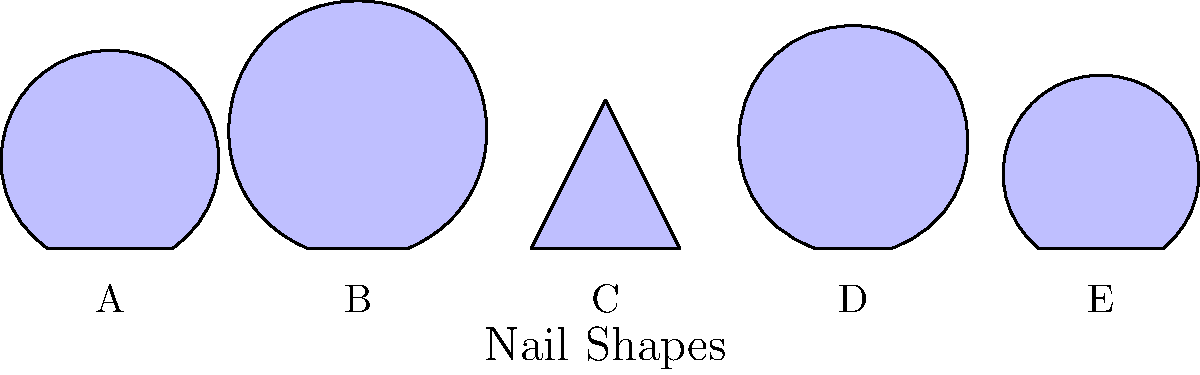Which nail shape shown in the diagram would be best suited for creating intricate, detailed nail art designs with multiple small elements? To determine the best nail shape for intricate, detailed nail art designs with multiple small elements, we need to consider the surface area and shape of each option:

1. Shape A: This shape has a moderate width and height, providing a good balance of space.
2. Shape B: This shape is tall and narrow, which might limit the space for intricate designs.
3. Shape C: This shape has a wide, flat top, offering the most surface area for detailed work.
4. Shape D: This shape is very narrow and pointed, which would make it challenging to create detailed designs.
5. Shape E: This shape has a moderate width but is shorter than A, providing less space overall.

The best shape for intricate, detailed nail art designs with multiple small elements would be the one that offers the most flat surface area. This allows for more space to create and showcase intricate designs.

Shape C provides the widest and flattest surface among all the options. Its broad, flat top offers the most space for creating detailed nail art with multiple small elements. The flat surface also ensures that the design can be easily viewed and appreciated from different angles.

Therefore, Shape C is the most suitable for creating intricate, detailed nail art designs with multiple small elements.
Answer: Shape C 